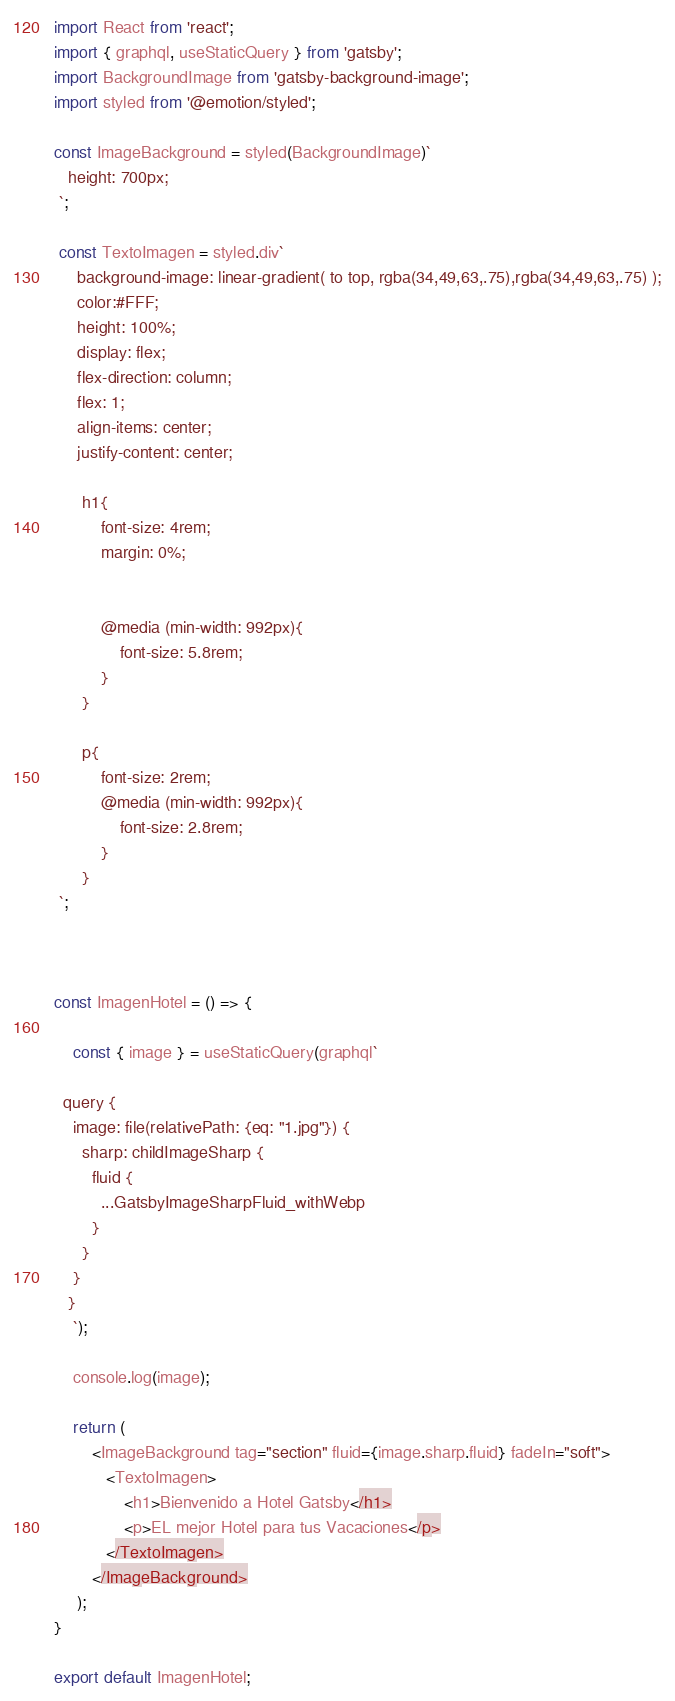Convert code to text. <code><loc_0><loc_0><loc_500><loc_500><_JavaScript_>import React from 'react';
import { graphql, useStaticQuery } from 'gatsby';
import BackgroundImage from 'gatsby-background-image';
import styled from '@emotion/styled';

const ImageBackground = styled(BackgroundImage)`
   height: 700px;
 `;

 const TextoImagen = styled.div`
     background-image: linear-gradient( to top, rgba(34,49,63,.75),rgba(34,49,63,.75) );
     color:#FFF;
     height: 100%;
     display: flex;
     flex-direction: column;
     flex: 1;
     align-items: center;
     justify-content: center;
      
      h1{
          font-size: 4rem;
          margin: 0%;


          @media (min-width: 992px){
              font-size: 5.8rem;
          }
      }

      p{
          font-size: 2rem;
          @media (min-width: 992px){
              font-size: 2.8rem;
          }
      }
 `;



const ImagenHotel = () => {
 
    const { image } = useStaticQuery(graphql`
    
  query {
    image: file(relativePath: {eq: "1.jpg"}) {
      sharp: childImageSharp {
        fluid {
          ...GatsbyImageSharpFluid_withWebp
        }
      }
    }
   }
    `);

    console.log(image);

    return ( 
        <ImageBackground tag="section" fluid={image.sharp.fluid} fadeIn="soft">
           <TextoImagen>
               <h1>Bienvenido a Hotel Gatsby</h1>
               <p>EL mejor Hotel para tus Vacaciones</p>
           </TextoImagen>
        </ImageBackground>
     );
}
 
export default ImagenHotel;</code> 